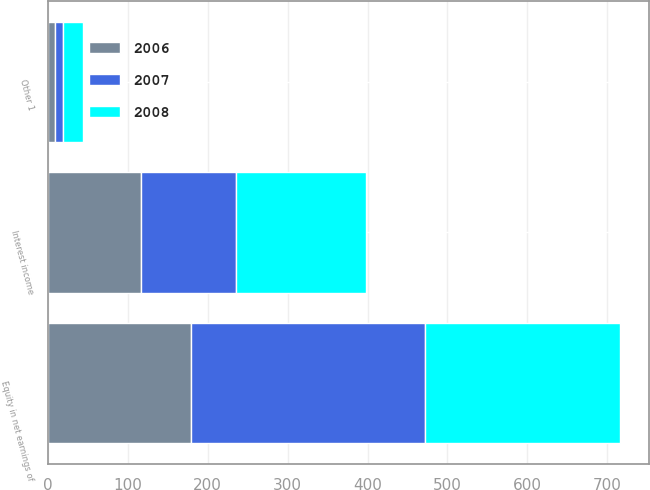Convert chart. <chart><loc_0><loc_0><loc_500><loc_500><stacked_bar_chart><ecel><fcel>Interest income<fcel>Equity in net earnings of<fcel>Other 1<nl><fcel>2007<fcel>119<fcel>293<fcel>10<nl><fcel>2008<fcel>162<fcel>244<fcel>25<nl><fcel>2006<fcel>117<fcel>179<fcel>9<nl></chart> 